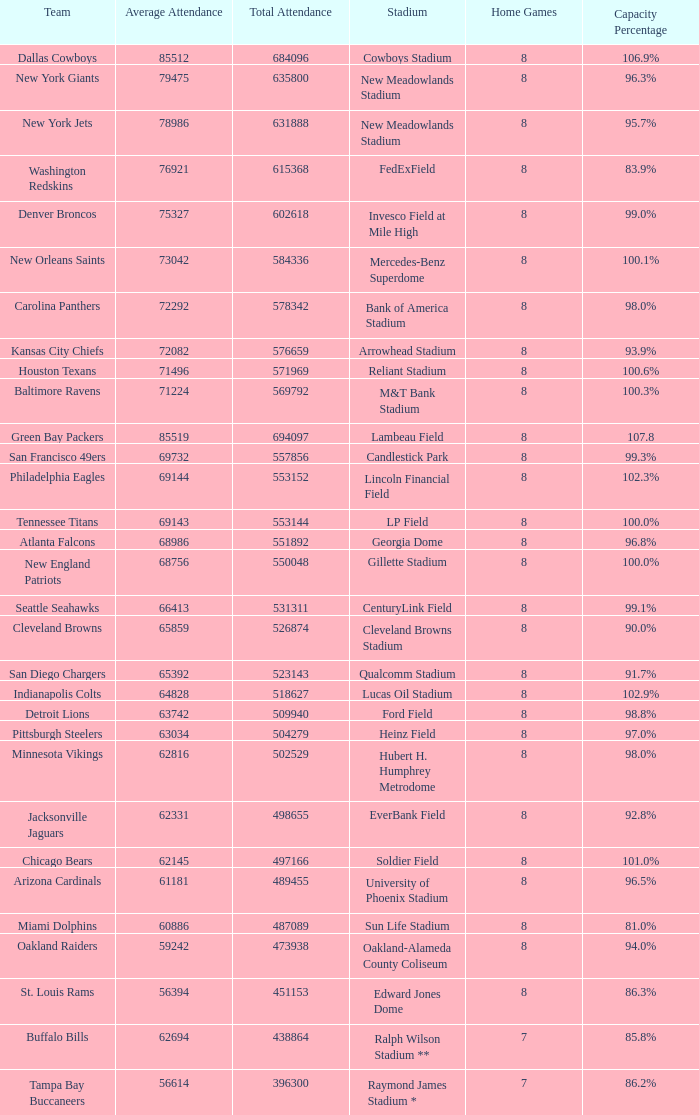How many home games are listed when the average attendance is 79475? 1.0. 